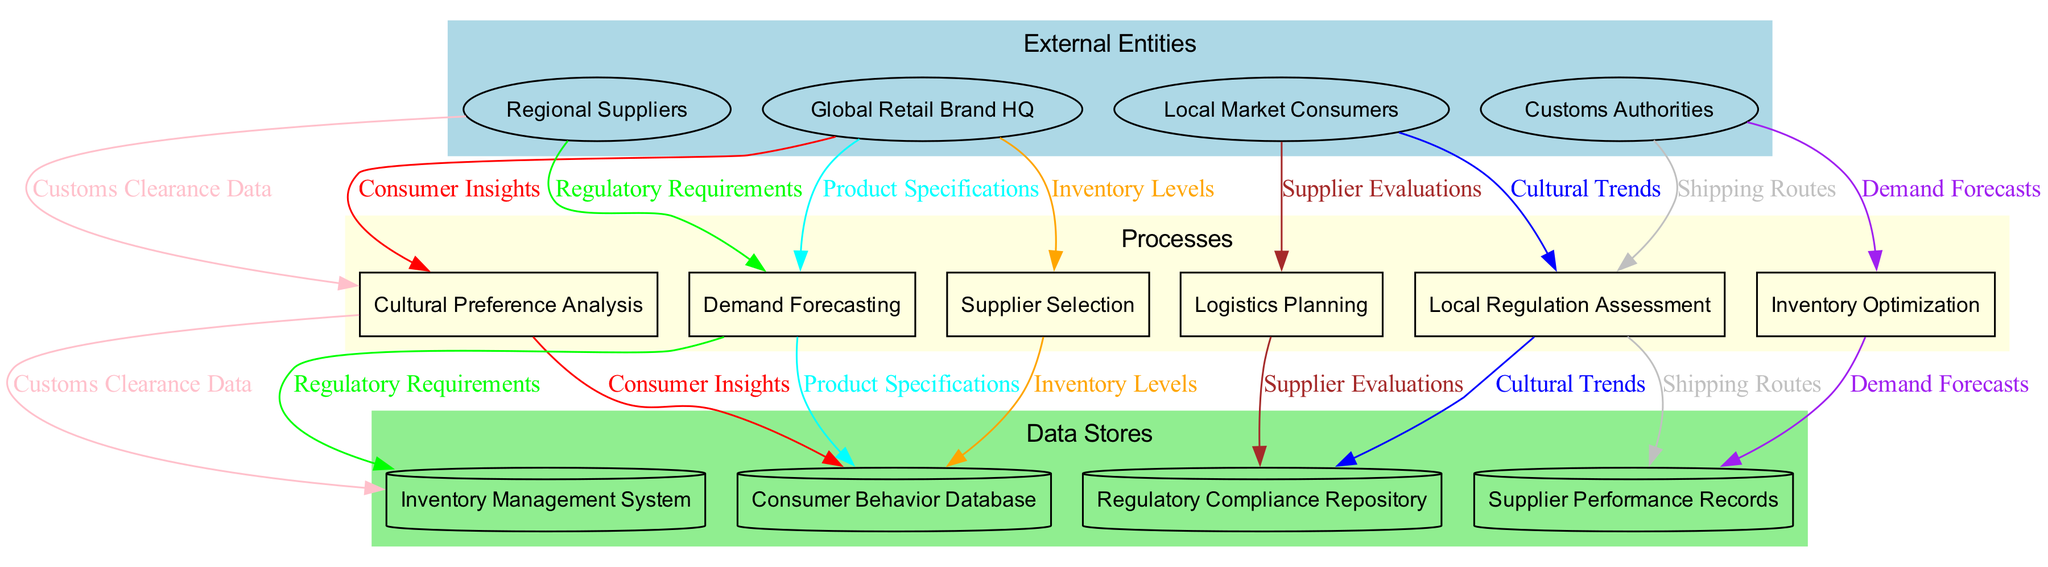What are the external entities in this diagram? The external entities are listed at the top of the diagram, and they include the Global Retail Brand HQ, Local Market Consumers, Regional Suppliers, and Customs Authorities.
Answer: Global Retail Brand HQ, Local Market Consumers, Regional Suppliers, Customs Authorities How many processes are present in the diagram? By counting the rectangles representing processes within the diagram, we find there are six distinct processes: Cultural Preference Analysis, Local Regulation Assessment, Demand Forecasting, Inventory Optimization, Supplier Selection, and Logistics Planning.
Answer: Six What data flow connects Local Market Consumers to the processes? The data flow from Local Market Consumers to the process of Cultural Preference Analysis shows the insights gathered from consumer behavior and preferences.
Answer: Consumer Insights Which data store is connected to the Inventory Optimization process? The diagram shows an edge leading from the Inventory Optimization process to the Inventory Management System data store, indicating that this process utilizes inventory data for optimization.
Answer: Inventory Management System Identify the relationship between cultural trends and demand forecasts. The Cultural Preference Analysis process outputs Cultural Trends which are then used as input for the Demand Forecasting process, indicating a flow of insights that inform demand predictions.
Answer: Cultural Trends inform Demand Forecasting Which process assesses local regulations? In the overview of processes in the diagram, one specifically labeled "Local Regulation Assessment" is dedicated to understanding and evaluating local regulations affecting supply chain operations.
Answer: Local Regulation Assessment How many data stores are listed? The diagram presents four different data stores: Consumer Behavior Database, Regulatory Compliance Repository, Inventory Management System, and Supplier Performance Records, indicating the various types of data being stored.
Answer: Four What role does the Customs Authorities play in the data flow? The Customs Authorities are represented as an external entity, providing essential Customs Clearance Data that flows to processes involved in logistics and shipment planning.
Answer: Supply chain clearance What connects the Supplier Selection process to the data stores? The Supplier Selection process has connections to the Supplier Performance Records data store, indicating that it uses supplier data for evaluating and selecting potential suppliers.
Answer: Supplier Performance Records Identify a data flow that goes to the Logistics Planning process. The diagram indicates that the Logistics Planning process receives Shipping Routes as a data flow, which are crucial for planning efficient logistics strategies.
Answer: Shipping Routes 